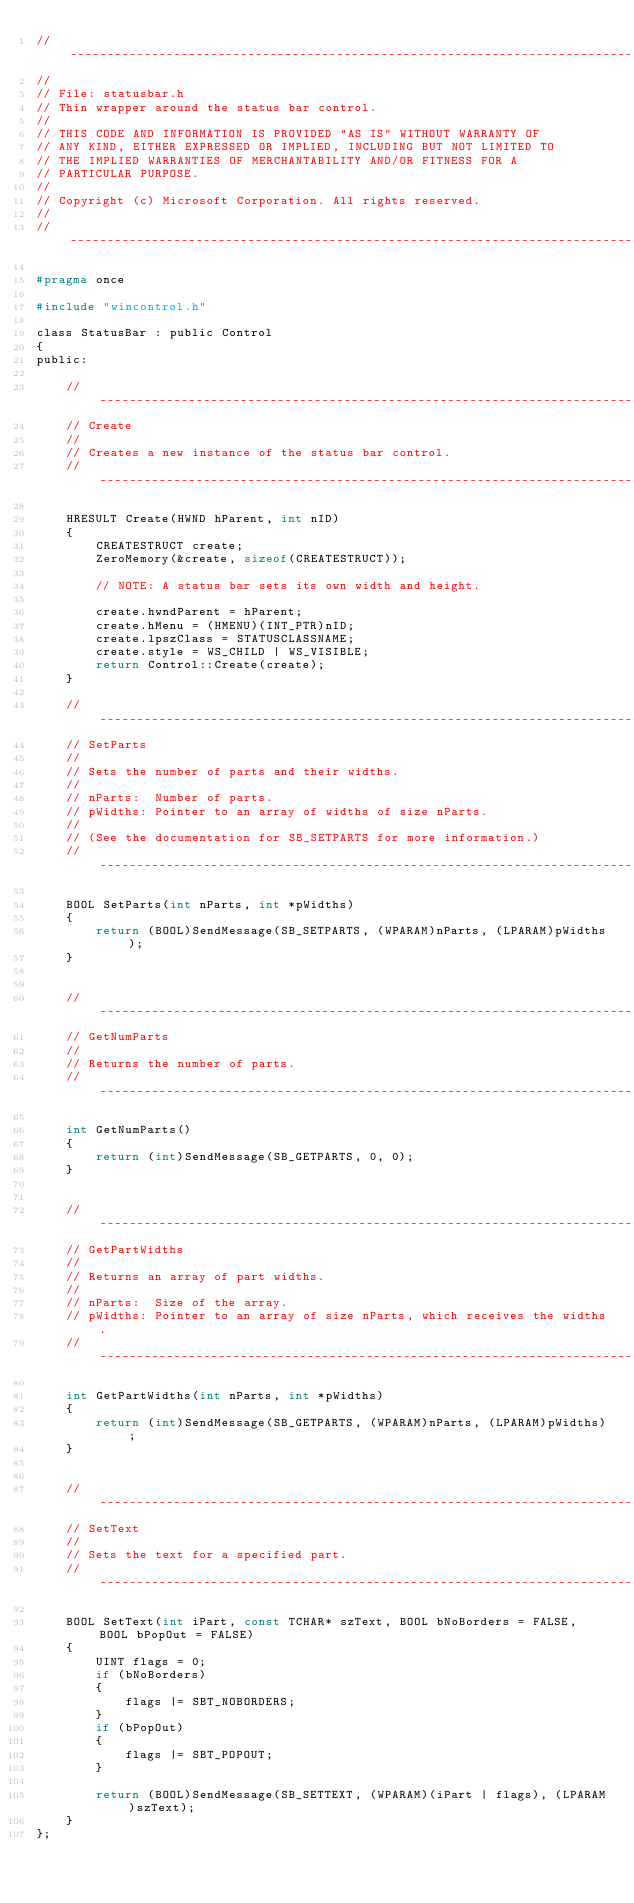Convert code to text. <code><loc_0><loc_0><loc_500><loc_500><_C_>//------------------------------------------------------------------------------
//
// File: statusbar.h
// Thin wrapper around the status bar control.
//
// THIS CODE AND INFORMATION IS PROVIDED "AS IS" WITHOUT WARRANTY OF
// ANY KIND, EITHER EXPRESSED OR IMPLIED, INCLUDING BUT NOT LIMITED TO
// THE IMPLIED WARRANTIES OF MERCHANTABILITY AND/OR FITNESS FOR A
// PARTICULAR PURPOSE.
//
// Copyright (c) Microsoft Corporation. All rights reserved.
//
//------------------------------------------------------------------------------

#pragma once

#include "wincontrol.h"

class StatusBar : public Control
{
public:

    //------------------------------------------------------------------------------
    // Create
    //
    // Creates a new instance of the status bar control.
    //------------------------------------------------------------------------------

    HRESULT Create(HWND hParent, int nID)
    {
        CREATESTRUCT create;
        ZeroMemory(&create, sizeof(CREATESTRUCT));

        // NOTE: A status bar sets its own width and height.

        create.hwndParent = hParent;
        create.hMenu = (HMENU)(INT_PTR)nID;
        create.lpszClass = STATUSCLASSNAME;
        create.style = WS_CHILD | WS_VISIBLE;
        return Control::Create(create);
    }

    //------------------------------------------------------------------------------
    // SetParts
    //
    // Sets the number of parts and their widths.
    //
    // nParts:  Number of parts.
    // pWidths: Pointer to an array of widths of size nParts.
    //
    // (See the documentation for SB_SETPARTS for more information.)
    //------------------------------------------------------------------------------

    BOOL SetParts(int nParts, int *pWidths)
    {
        return (BOOL)SendMessage(SB_SETPARTS, (WPARAM)nParts, (LPARAM)pWidths);
    }


    //------------------------------------------------------------------------------
    // GetNumParts
    //
    // Returns the number of parts.
    //------------------------------------------------------------------------------

    int GetNumParts()
    {
        return (int)SendMessage(SB_GETPARTS, 0, 0);
    }


    //------------------------------------------------------------------------------
    // GetPartWidths
    //
    // Returns an array of part widths.
    //
    // nParts:  Size of the array.
    // pWidths: Pointer to an array of size nParts, which receives the widths.
    //------------------------------------------------------------------------------

    int GetPartWidths(int nParts, int *pWidths)
    {
        return (int)SendMessage(SB_GETPARTS, (WPARAM)nParts, (LPARAM)pWidths);
    }


    //------------------------------------------------------------------------------
    // SetText
    //
    // Sets the text for a specified part.
    //------------------------------------------------------------------------------

    BOOL SetText(int iPart, const TCHAR* szText, BOOL bNoBorders = FALSE, BOOL bPopOut = FALSE)
    {
        UINT flags = 0;
        if (bNoBorders) 
        { 
            flags |= SBT_NOBORDERS;
        }
        if (bPopOut)
        {
            flags |= SBT_POPOUT;
        }

        return (BOOL)SendMessage(SB_SETTEXT, (WPARAM)(iPart | flags), (LPARAM)szText);
    }
};</code> 